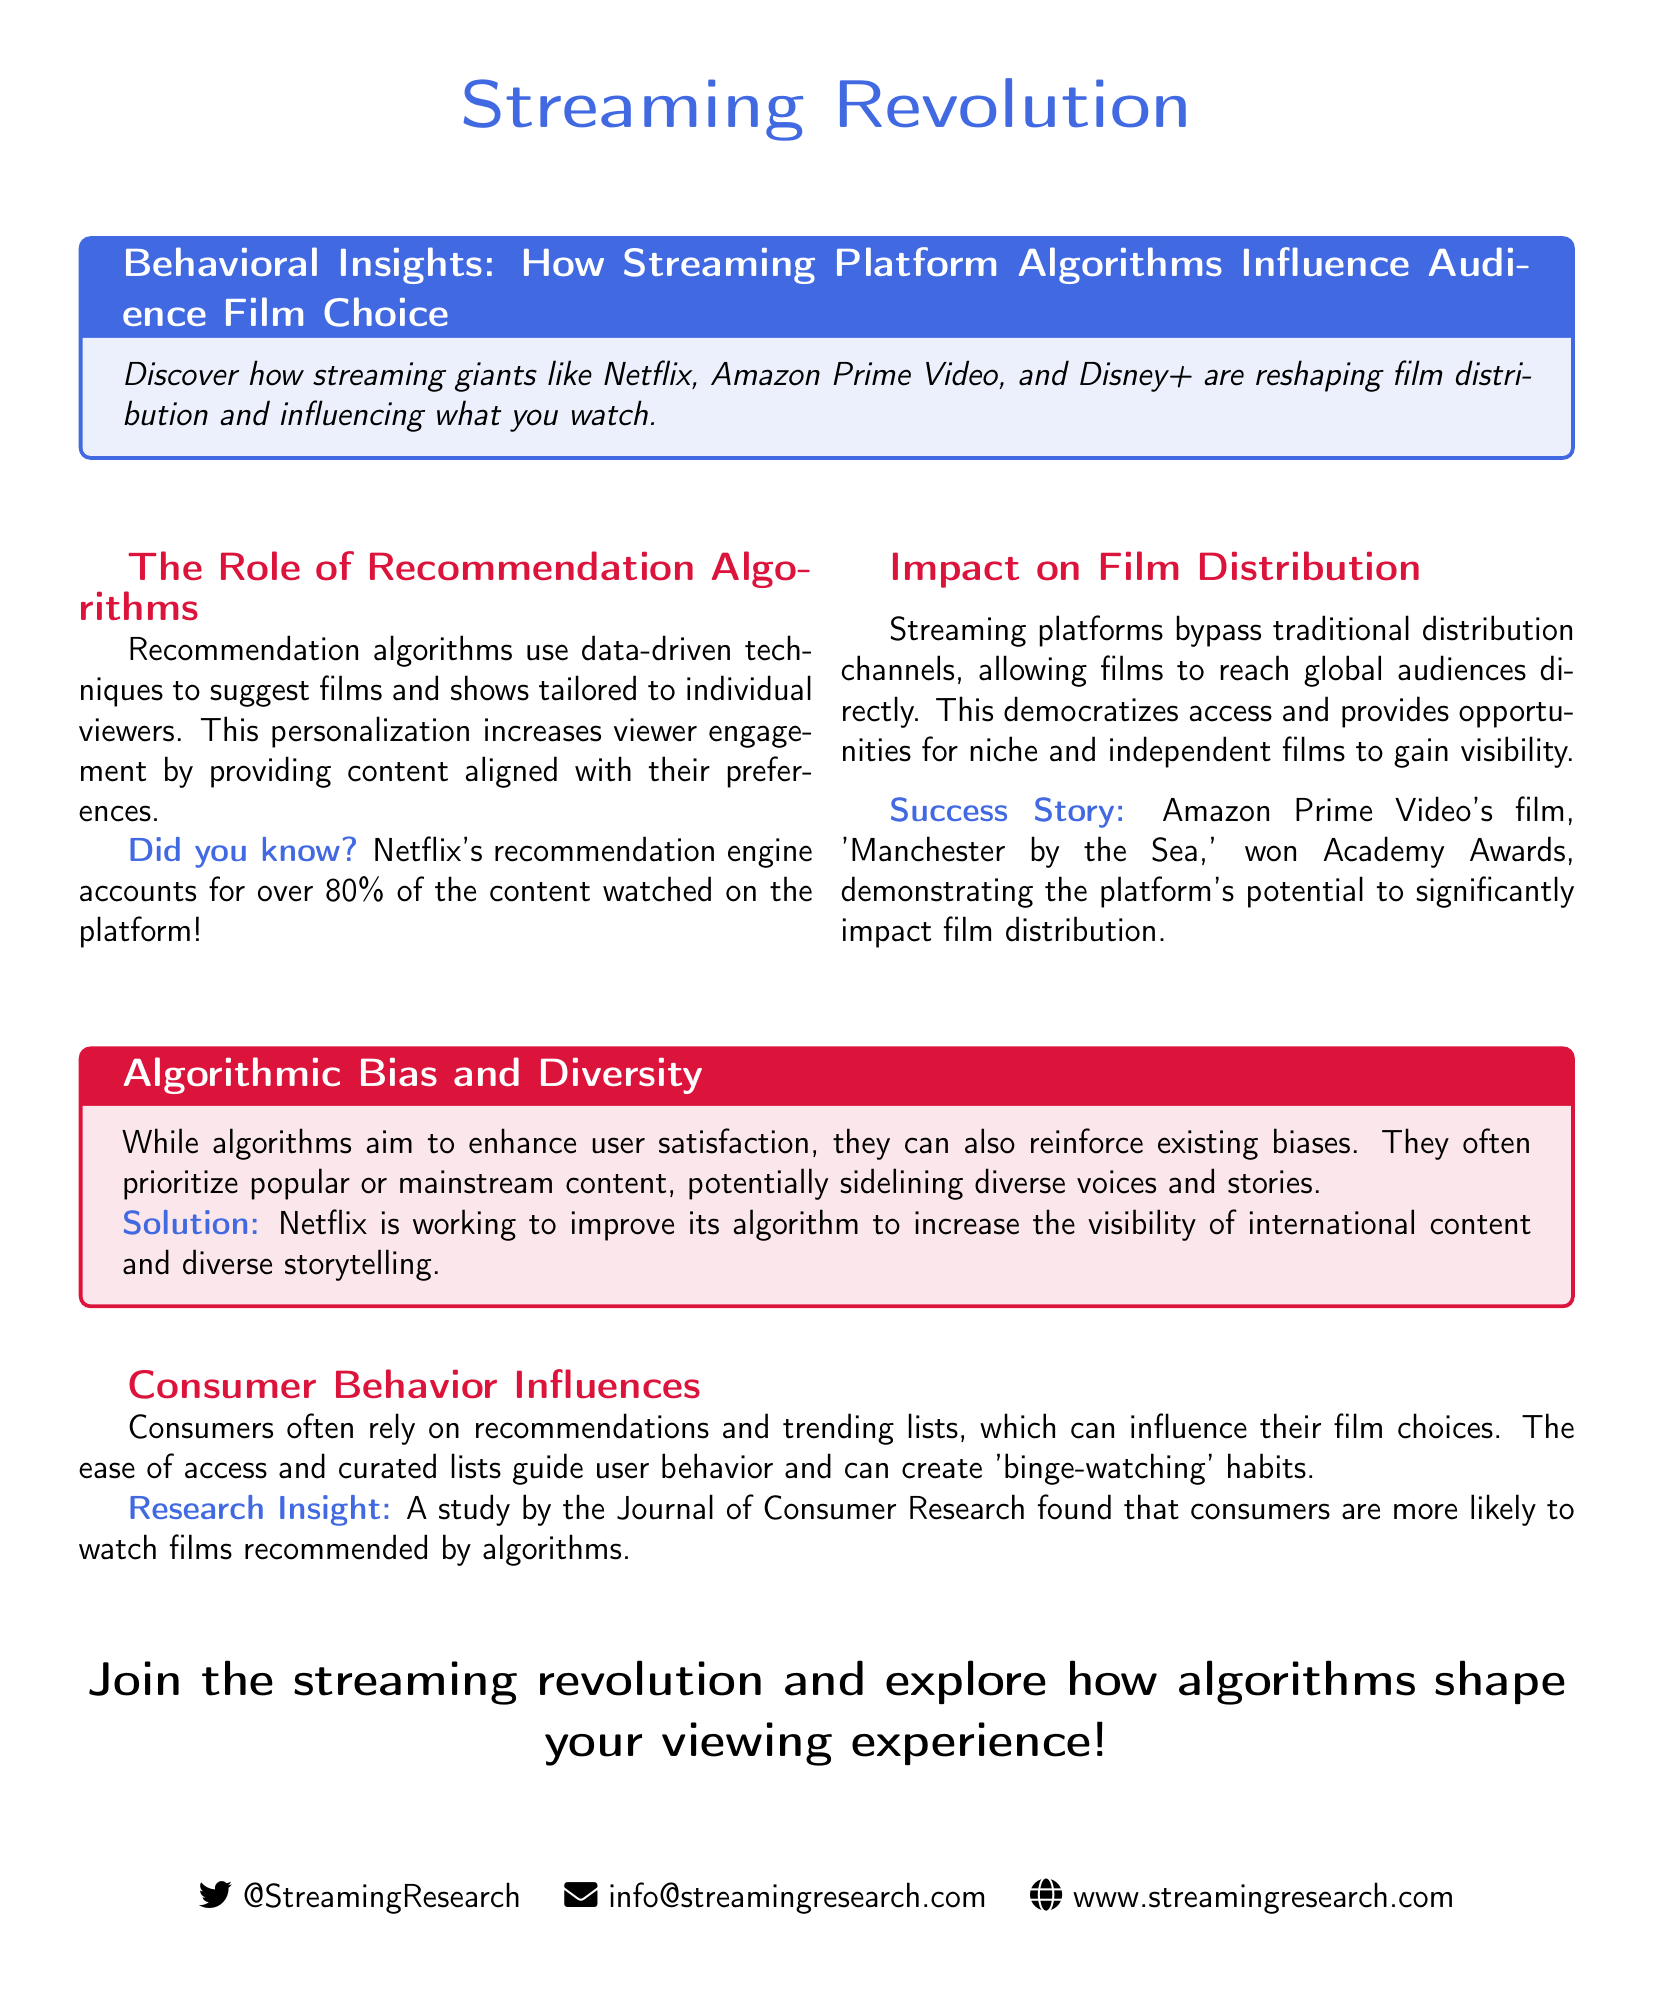What is the title of the advertisement? The title is found in the header of the advertisement within the tcolorbox section.
Answer: Behavioral Insights: How Streaming Platform Algorithms Influence Audience Film Choice What percentage of content watched on Netflix is due to the recommendation engine? The document explicitly states the percentage in the section about recommendation algorithms.
Answer: 80% What film won Academy Awards through Amazon Prime Video? This information is located in the success story section regarding film distribution.
Answer: Manchester by the Sea What is a potential issue with recommendation algorithms highlighted in the document? This issue is addressed in the tcolorbox discussing algorithmic bias and diversity.
Answer: Reinforce existing biases Which platform is mentioned for working to improve its algorithm for diverse storytelling? This detail can be found in the algorithmic bias and diversity section.
Answer: Netflix What research publication is cited regarding consumer behavior? The source of the study is mentioned in the insights about consumer behavior influences.
Answer: Journal of Consumer Research What color is used for the main header of the advertisement? The color for the header text is specified at the start of the document.
Answer: Streaming blue What type of document is this article? The document is identified as an advertisement based on its structure and content purpose.
Answer: Advertisement 